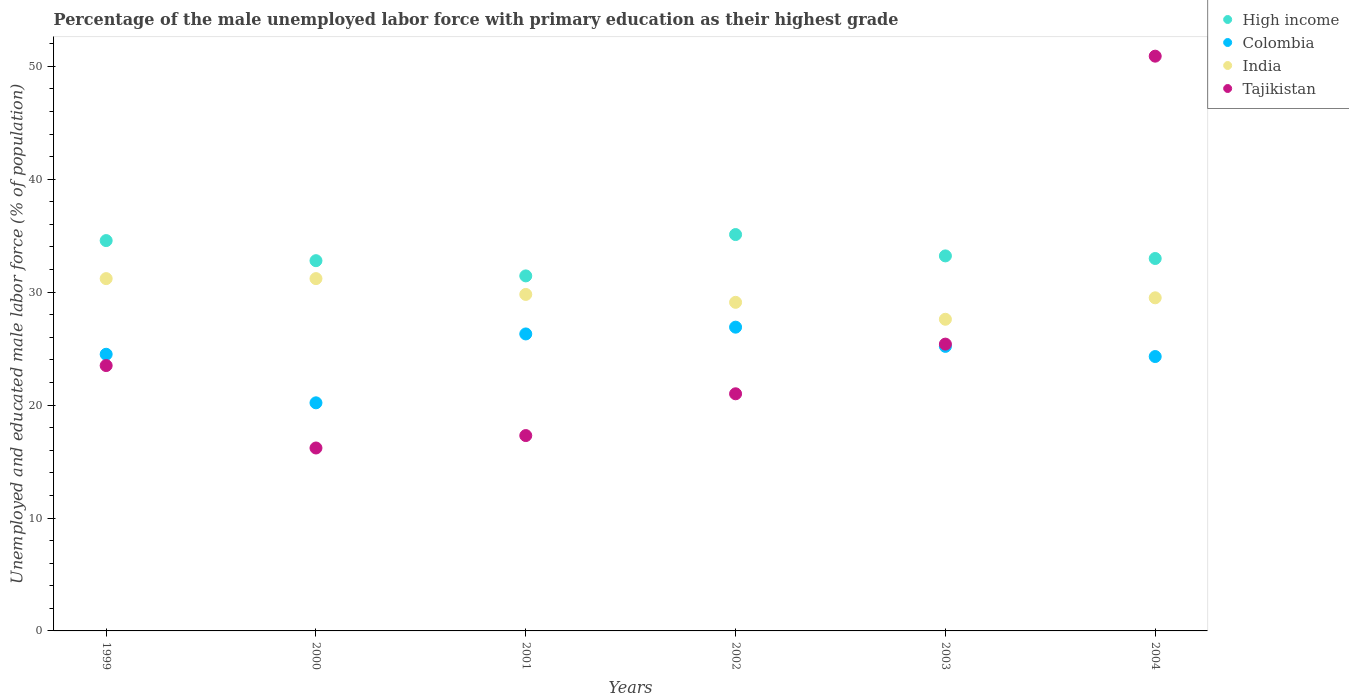How many different coloured dotlines are there?
Make the answer very short. 4. What is the percentage of the unemployed male labor force with primary education in Colombia in 1999?
Keep it short and to the point. 24.5. Across all years, what is the maximum percentage of the unemployed male labor force with primary education in India?
Provide a short and direct response. 31.2. Across all years, what is the minimum percentage of the unemployed male labor force with primary education in India?
Offer a terse response. 27.6. What is the total percentage of the unemployed male labor force with primary education in Colombia in the graph?
Provide a short and direct response. 147.4. What is the difference between the percentage of the unemployed male labor force with primary education in Tajikistan in 2001 and that in 2002?
Provide a short and direct response. -3.7. What is the difference between the percentage of the unemployed male labor force with primary education in Colombia in 1999 and the percentage of the unemployed male labor force with primary education in High income in 2001?
Offer a very short reply. -6.94. What is the average percentage of the unemployed male labor force with primary education in India per year?
Keep it short and to the point. 29.73. What is the ratio of the percentage of the unemployed male labor force with primary education in Tajikistan in 2000 to that in 2004?
Keep it short and to the point. 0.32. Is the percentage of the unemployed male labor force with primary education in India in 2002 less than that in 2004?
Ensure brevity in your answer.  Yes. Is the difference between the percentage of the unemployed male labor force with primary education in India in 2000 and 2003 greater than the difference between the percentage of the unemployed male labor force with primary education in Tajikistan in 2000 and 2003?
Your answer should be very brief. Yes. What is the difference between the highest and the second highest percentage of the unemployed male labor force with primary education in India?
Your response must be concise. 0. What is the difference between the highest and the lowest percentage of the unemployed male labor force with primary education in India?
Offer a very short reply. 3.6. Is the sum of the percentage of the unemployed male labor force with primary education in Colombia in 2000 and 2004 greater than the maximum percentage of the unemployed male labor force with primary education in India across all years?
Your answer should be compact. Yes. Is the percentage of the unemployed male labor force with primary education in High income strictly greater than the percentage of the unemployed male labor force with primary education in Colombia over the years?
Offer a terse response. Yes. Is the percentage of the unemployed male labor force with primary education in High income strictly less than the percentage of the unemployed male labor force with primary education in Tajikistan over the years?
Provide a short and direct response. No. How many years are there in the graph?
Provide a succinct answer. 6. How many legend labels are there?
Provide a succinct answer. 4. What is the title of the graph?
Give a very brief answer. Percentage of the male unemployed labor force with primary education as their highest grade. Does "Israel" appear as one of the legend labels in the graph?
Make the answer very short. No. What is the label or title of the Y-axis?
Give a very brief answer. Unemployed and educated male labor force (% of population). What is the Unemployed and educated male labor force (% of population) of High income in 1999?
Your response must be concise. 34.57. What is the Unemployed and educated male labor force (% of population) of Colombia in 1999?
Ensure brevity in your answer.  24.5. What is the Unemployed and educated male labor force (% of population) of India in 1999?
Keep it short and to the point. 31.2. What is the Unemployed and educated male labor force (% of population) of High income in 2000?
Offer a very short reply. 32.79. What is the Unemployed and educated male labor force (% of population) of Colombia in 2000?
Make the answer very short. 20.2. What is the Unemployed and educated male labor force (% of population) of India in 2000?
Keep it short and to the point. 31.2. What is the Unemployed and educated male labor force (% of population) in Tajikistan in 2000?
Offer a terse response. 16.2. What is the Unemployed and educated male labor force (% of population) in High income in 2001?
Your answer should be compact. 31.44. What is the Unemployed and educated male labor force (% of population) of Colombia in 2001?
Your response must be concise. 26.3. What is the Unemployed and educated male labor force (% of population) in India in 2001?
Keep it short and to the point. 29.8. What is the Unemployed and educated male labor force (% of population) of Tajikistan in 2001?
Ensure brevity in your answer.  17.3. What is the Unemployed and educated male labor force (% of population) of High income in 2002?
Your answer should be compact. 35.1. What is the Unemployed and educated male labor force (% of population) in Colombia in 2002?
Provide a short and direct response. 26.9. What is the Unemployed and educated male labor force (% of population) in India in 2002?
Your answer should be compact. 29.1. What is the Unemployed and educated male labor force (% of population) in Tajikistan in 2002?
Give a very brief answer. 21. What is the Unemployed and educated male labor force (% of population) in High income in 2003?
Provide a short and direct response. 33.21. What is the Unemployed and educated male labor force (% of population) in Colombia in 2003?
Keep it short and to the point. 25.2. What is the Unemployed and educated male labor force (% of population) of India in 2003?
Give a very brief answer. 27.6. What is the Unemployed and educated male labor force (% of population) of Tajikistan in 2003?
Give a very brief answer. 25.4. What is the Unemployed and educated male labor force (% of population) of High income in 2004?
Make the answer very short. 32.98. What is the Unemployed and educated male labor force (% of population) of Colombia in 2004?
Give a very brief answer. 24.3. What is the Unemployed and educated male labor force (% of population) of India in 2004?
Provide a short and direct response. 29.5. What is the Unemployed and educated male labor force (% of population) of Tajikistan in 2004?
Your answer should be very brief. 50.9. Across all years, what is the maximum Unemployed and educated male labor force (% of population) in High income?
Your answer should be compact. 35.1. Across all years, what is the maximum Unemployed and educated male labor force (% of population) of Colombia?
Keep it short and to the point. 26.9. Across all years, what is the maximum Unemployed and educated male labor force (% of population) in India?
Provide a short and direct response. 31.2. Across all years, what is the maximum Unemployed and educated male labor force (% of population) in Tajikistan?
Ensure brevity in your answer.  50.9. Across all years, what is the minimum Unemployed and educated male labor force (% of population) in High income?
Your answer should be very brief. 31.44. Across all years, what is the minimum Unemployed and educated male labor force (% of population) of Colombia?
Make the answer very short. 20.2. Across all years, what is the minimum Unemployed and educated male labor force (% of population) of India?
Your response must be concise. 27.6. Across all years, what is the minimum Unemployed and educated male labor force (% of population) of Tajikistan?
Provide a short and direct response. 16.2. What is the total Unemployed and educated male labor force (% of population) of High income in the graph?
Give a very brief answer. 200.09. What is the total Unemployed and educated male labor force (% of population) of Colombia in the graph?
Provide a succinct answer. 147.4. What is the total Unemployed and educated male labor force (% of population) in India in the graph?
Your answer should be very brief. 178.4. What is the total Unemployed and educated male labor force (% of population) of Tajikistan in the graph?
Keep it short and to the point. 154.3. What is the difference between the Unemployed and educated male labor force (% of population) of High income in 1999 and that in 2000?
Keep it short and to the point. 1.78. What is the difference between the Unemployed and educated male labor force (% of population) in Colombia in 1999 and that in 2000?
Give a very brief answer. 4.3. What is the difference between the Unemployed and educated male labor force (% of population) of India in 1999 and that in 2000?
Make the answer very short. 0. What is the difference between the Unemployed and educated male labor force (% of population) in Tajikistan in 1999 and that in 2000?
Provide a short and direct response. 7.3. What is the difference between the Unemployed and educated male labor force (% of population) of High income in 1999 and that in 2001?
Offer a terse response. 3.13. What is the difference between the Unemployed and educated male labor force (% of population) in High income in 1999 and that in 2002?
Offer a terse response. -0.53. What is the difference between the Unemployed and educated male labor force (% of population) in Tajikistan in 1999 and that in 2002?
Your answer should be compact. 2.5. What is the difference between the Unemployed and educated male labor force (% of population) in High income in 1999 and that in 2003?
Your answer should be compact. 1.36. What is the difference between the Unemployed and educated male labor force (% of population) of Colombia in 1999 and that in 2003?
Provide a short and direct response. -0.7. What is the difference between the Unemployed and educated male labor force (% of population) of India in 1999 and that in 2003?
Keep it short and to the point. 3.6. What is the difference between the Unemployed and educated male labor force (% of population) of High income in 1999 and that in 2004?
Your response must be concise. 1.59. What is the difference between the Unemployed and educated male labor force (% of population) in Colombia in 1999 and that in 2004?
Your answer should be compact. 0.2. What is the difference between the Unemployed and educated male labor force (% of population) in Tajikistan in 1999 and that in 2004?
Provide a short and direct response. -27.4. What is the difference between the Unemployed and educated male labor force (% of population) of High income in 2000 and that in 2001?
Offer a very short reply. 1.35. What is the difference between the Unemployed and educated male labor force (% of population) in Colombia in 2000 and that in 2001?
Your answer should be very brief. -6.1. What is the difference between the Unemployed and educated male labor force (% of population) of India in 2000 and that in 2001?
Ensure brevity in your answer.  1.4. What is the difference between the Unemployed and educated male labor force (% of population) of High income in 2000 and that in 2002?
Offer a terse response. -2.31. What is the difference between the Unemployed and educated male labor force (% of population) of India in 2000 and that in 2002?
Your response must be concise. 2.1. What is the difference between the Unemployed and educated male labor force (% of population) in Tajikistan in 2000 and that in 2002?
Offer a terse response. -4.8. What is the difference between the Unemployed and educated male labor force (% of population) of High income in 2000 and that in 2003?
Make the answer very short. -0.42. What is the difference between the Unemployed and educated male labor force (% of population) in India in 2000 and that in 2003?
Your response must be concise. 3.6. What is the difference between the Unemployed and educated male labor force (% of population) in Tajikistan in 2000 and that in 2003?
Provide a short and direct response. -9.2. What is the difference between the Unemployed and educated male labor force (% of population) of High income in 2000 and that in 2004?
Provide a short and direct response. -0.19. What is the difference between the Unemployed and educated male labor force (% of population) in Colombia in 2000 and that in 2004?
Offer a very short reply. -4.1. What is the difference between the Unemployed and educated male labor force (% of population) in Tajikistan in 2000 and that in 2004?
Make the answer very short. -34.7. What is the difference between the Unemployed and educated male labor force (% of population) of High income in 2001 and that in 2002?
Your response must be concise. -3.66. What is the difference between the Unemployed and educated male labor force (% of population) in Colombia in 2001 and that in 2002?
Provide a short and direct response. -0.6. What is the difference between the Unemployed and educated male labor force (% of population) in India in 2001 and that in 2002?
Provide a succinct answer. 0.7. What is the difference between the Unemployed and educated male labor force (% of population) in Tajikistan in 2001 and that in 2002?
Provide a succinct answer. -3.7. What is the difference between the Unemployed and educated male labor force (% of population) in High income in 2001 and that in 2003?
Your answer should be compact. -1.77. What is the difference between the Unemployed and educated male labor force (% of population) of India in 2001 and that in 2003?
Provide a short and direct response. 2.2. What is the difference between the Unemployed and educated male labor force (% of population) in High income in 2001 and that in 2004?
Provide a succinct answer. -1.54. What is the difference between the Unemployed and educated male labor force (% of population) in Colombia in 2001 and that in 2004?
Make the answer very short. 2. What is the difference between the Unemployed and educated male labor force (% of population) of Tajikistan in 2001 and that in 2004?
Your response must be concise. -33.6. What is the difference between the Unemployed and educated male labor force (% of population) of High income in 2002 and that in 2003?
Your answer should be compact. 1.89. What is the difference between the Unemployed and educated male labor force (% of population) of India in 2002 and that in 2003?
Provide a short and direct response. 1.5. What is the difference between the Unemployed and educated male labor force (% of population) of High income in 2002 and that in 2004?
Offer a terse response. 2.12. What is the difference between the Unemployed and educated male labor force (% of population) of India in 2002 and that in 2004?
Keep it short and to the point. -0.4. What is the difference between the Unemployed and educated male labor force (% of population) in Tajikistan in 2002 and that in 2004?
Provide a short and direct response. -29.9. What is the difference between the Unemployed and educated male labor force (% of population) in High income in 2003 and that in 2004?
Provide a succinct answer. 0.23. What is the difference between the Unemployed and educated male labor force (% of population) in Colombia in 2003 and that in 2004?
Provide a succinct answer. 0.9. What is the difference between the Unemployed and educated male labor force (% of population) of Tajikistan in 2003 and that in 2004?
Provide a succinct answer. -25.5. What is the difference between the Unemployed and educated male labor force (% of population) in High income in 1999 and the Unemployed and educated male labor force (% of population) in Colombia in 2000?
Offer a terse response. 14.37. What is the difference between the Unemployed and educated male labor force (% of population) of High income in 1999 and the Unemployed and educated male labor force (% of population) of India in 2000?
Your response must be concise. 3.37. What is the difference between the Unemployed and educated male labor force (% of population) in High income in 1999 and the Unemployed and educated male labor force (% of population) in Tajikistan in 2000?
Offer a terse response. 18.37. What is the difference between the Unemployed and educated male labor force (% of population) of India in 1999 and the Unemployed and educated male labor force (% of population) of Tajikistan in 2000?
Your response must be concise. 15. What is the difference between the Unemployed and educated male labor force (% of population) of High income in 1999 and the Unemployed and educated male labor force (% of population) of Colombia in 2001?
Make the answer very short. 8.27. What is the difference between the Unemployed and educated male labor force (% of population) of High income in 1999 and the Unemployed and educated male labor force (% of population) of India in 2001?
Your answer should be very brief. 4.77. What is the difference between the Unemployed and educated male labor force (% of population) of High income in 1999 and the Unemployed and educated male labor force (% of population) of Tajikistan in 2001?
Keep it short and to the point. 17.27. What is the difference between the Unemployed and educated male labor force (% of population) in Colombia in 1999 and the Unemployed and educated male labor force (% of population) in Tajikistan in 2001?
Provide a short and direct response. 7.2. What is the difference between the Unemployed and educated male labor force (% of population) of India in 1999 and the Unemployed and educated male labor force (% of population) of Tajikistan in 2001?
Offer a very short reply. 13.9. What is the difference between the Unemployed and educated male labor force (% of population) of High income in 1999 and the Unemployed and educated male labor force (% of population) of Colombia in 2002?
Keep it short and to the point. 7.67. What is the difference between the Unemployed and educated male labor force (% of population) of High income in 1999 and the Unemployed and educated male labor force (% of population) of India in 2002?
Your response must be concise. 5.47. What is the difference between the Unemployed and educated male labor force (% of population) in High income in 1999 and the Unemployed and educated male labor force (% of population) in Tajikistan in 2002?
Offer a terse response. 13.57. What is the difference between the Unemployed and educated male labor force (% of population) in High income in 1999 and the Unemployed and educated male labor force (% of population) in Colombia in 2003?
Provide a succinct answer. 9.37. What is the difference between the Unemployed and educated male labor force (% of population) in High income in 1999 and the Unemployed and educated male labor force (% of population) in India in 2003?
Offer a very short reply. 6.97. What is the difference between the Unemployed and educated male labor force (% of population) in High income in 1999 and the Unemployed and educated male labor force (% of population) in Tajikistan in 2003?
Ensure brevity in your answer.  9.17. What is the difference between the Unemployed and educated male labor force (% of population) in Colombia in 1999 and the Unemployed and educated male labor force (% of population) in India in 2003?
Offer a very short reply. -3.1. What is the difference between the Unemployed and educated male labor force (% of population) in India in 1999 and the Unemployed and educated male labor force (% of population) in Tajikistan in 2003?
Your response must be concise. 5.8. What is the difference between the Unemployed and educated male labor force (% of population) in High income in 1999 and the Unemployed and educated male labor force (% of population) in Colombia in 2004?
Your answer should be very brief. 10.27. What is the difference between the Unemployed and educated male labor force (% of population) of High income in 1999 and the Unemployed and educated male labor force (% of population) of India in 2004?
Give a very brief answer. 5.07. What is the difference between the Unemployed and educated male labor force (% of population) of High income in 1999 and the Unemployed and educated male labor force (% of population) of Tajikistan in 2004?
Your answer should be very brief. -16.33. What is the difference between the Unemployed and educated male labor force (% of population) in Colombia in 1999 and the Unemployed and educated male labor force (% of population) in Tajikistan in 2004?
Offer a terse response. -26.4. What is the difference between the Unemployed and educated male labor force (% of population) in India in 1999 and the Unemployed and educated male labor force (% of population) in Tajikistan in 2004?
Keep it short and to the point. -19.7. What is the difference between the Unemployed and educated male labor force (% of population) of High income in 2000 and the Unemployed and educated male labor force (% of population) of Colombia in 2001?
Your response must be concise. 6.49. What is the difference between the Unemployed and educated male labor force (% of population) in High income in 2000 and the Unemployed and educated male labor force (% of population) in India in 2001?
Your answer should be compact. 2.99. What is the difference between the Unemployed and educated male labor force (% of population) in High income in 2000 and the Unemployed and educated male labor force (% of population) in Tajikistan in 2001?
Keep it short and to the point. 15.49. What is the difference between the Unemployed and educated male labor force (% of population) of Colombia in 2000 and the Unemployed and educated male labor force (% of population) of India in 2001?
Give a very brief answer. -9.6. What is the difference between the Unemployed and educated male labor force (% of population) of India in 2000 and the Unemployed and educated male labor force (% of population) of Tajikistan in 2001?
Your answer should be very brief. 13.9. What is the difference between the Unemployed and educated male labor force (% of population) in High income in 2000 and the Unemployed and educated male labor force (% of population) in Colombia in 2002?
Provide a short and direct response. 5.89. What is the difference between the Unemployed and educated male labor force (% of population) in High income in 2000 and the Unemployed and educated male labor force (% of population) in India in 2002?
Make the answer very short. 3.69. What is the difference between the Unemployed and educated male labor force (% of population) in High income in 2000 and the Unemployed and educated male labor force (% of population) in Tajikistan in 2002?
Provide a short and direct response. 11.79. What is the difference between the Unemployed and educated male labor force (% of population) of Colombia in 2000 and the Unemployed and educated male labor force (% of population) of India in 2002?
Give a very brief answer. -8.9. What is the difference between the Unemployed and educated male labor force (% of population) in India in 2000 and the Unemployed and educated male labor force (% of population) in Tajikistan in 2002?
Provide a short and direct response. 10.2. What is the difference between the Unemployed and educated male labor force (% of population) of High income in 2000 and the Unemployed and educated male labor force (% of population) of Colombia in 2003?
Your response must be concise. 7.59. What is the difference between the Unemployed and educated male labor force (% of population) of High income in 2000 and the Unemployed and educated male labor force (% of population) of India in 2003?
Give a very brief answer. 5.19. What is the difference between the Unemployed and educated male labor force (% of population) in High income in 2000 and the Unemployed and educated male labor force (% of population) in Tajikistan in 2003?
Offer a very short reply. 7.39. What is the difference between the Unemployed and educated male labor force (% of population) of India in 2000 and the Unemployed and educated male labor force (% of population) of Tajikistan in 2003?
Offer a terse response. 5.8. What is the difference between the Unemployed and educated male labor force (% of population) of High income in 2000 and the Unemployed and educated male labor force (% of population) of Colombia in 2004?
Offer a terse response. 8.49. What is the difference between the Unemployed and educated male labor force (% of population) of High income in 2000 and the Unemployed and educated male labor force (% of population) of India in 2004?
Make the answer very short. 3.29. What is the difference between the Unemployed and educated male labor force (% of population) in High income in 2000 and the Unemployed and educated male labor force (% of population) in Tajikistan in 2004?
Your answer should be very brief. -18.11. What is the difference between the Unemployed and educated male labor force (% of population) in Colombia in 2000 and the Unemployed and educated male labor force (% of population) in Tajikistan in 2004?
Make the answer very short. -30.7. What is the difference between the Unemployed and educated male labor force (% of population) in India in 2000 and the Unemployed and educated male labor force (% of population) in Tajikistan in 2004?
Provide a succinct answer. -19.7. What is the difference between the Unemployed and educated male labor force (% of population) of High income in 2001 and the Unemployed and educated male labor force (% of population) of Colombia in 2002?
Your response must be concise. 4.54. What is the difference between the Unemployed and educated male labor force (% of population) of High income in 2001 and the Unemployed and educated male labor force (% of population) of India in 2002?
Your response must be concise. 2.34. What is the difference between the Unemployed and educated male labor force (% of population) of High income in 2001 and the Unemployed and educated male labor force (% of population) of Tajikistan in 2002?
Provide a short and direct response. 10.44. What is the difference between the Unemployed and educated male labor force (% of population) of High income in 2001 and the Unemployed and educated male labor force (% of population) of Colombia in 2003?
Make the answer very short. 6.24. What is the difference between the Unemployed and educated male labor force (% of population) in High income in 2001 and the Unemployed and educated male labor force (% of population) in India in 2003?
Your answer should be very brief. 3.84. What is the difference between the Unemployed and educated male labor force (% of population) of High income in 2001 and the Unemployed and educated male labor force (% of population) of Tajikistan in 2003?
Make the answer very short. 6.04. What is the difference between the Unemployed and educated male labor force (% of population) in Colombia in 2001 and the Unemployed and educated male labor force (% of population) in India in 2003?
Your answer should be compact. -1.3. What is the difference between the Unemployed and educated male labor force (% of population) of India in 2001 and the Unemployed and educated male labor force (% of population) of Tajikistan in 2003?
Provide a short and direct response. 4.4. What is the difference between the Unemployed and educated male labor force (% of population) of High income in 2001 and the Unemployed and educated male labor force (% of population) of Colombia in 2004?
Offer a terse response. 7.14. What is the difference between the Unemployed and educated male labor force (% of population) of High income in 2001 and the Unemployed and educated male labor force (% of population) of India in 2004?
Keep it short and to the point. 1.94. What is the difference between the Unemployed and educated male labor force (% of population) of High income in 2001 and the Unemployed and educated male labor force (% of population) of Tajikistan in 2004?
Your response must be concise. -19.46. What is the difference between the Unemployed and educated male labor force (% of population) of Colombia in 2001 and the Unemployed and educated male labor force (% of population) of India in 2004?
Offer a terse response. -3.2. What is the difference between the Unemployed and educated male labor force (% of population) in Colombia in 2001 and the Unemployed and educated male labor force (% of population) in Tajikistan in 2004?
Ensure brevity in your answer.  -24.6. What is the difference between the Unemployed and educated male labor force (% of population) of India in 2001 and the Unemployed and educated male labor force (% of population) of Tajikistan in 2004?
Offer a terse response. -21.1. What is the difference between the Unemployed and educated male labor force (% of population) in High income in 2002 and the Unemployed and educated male labor force (% of population) in Colombia in 2003?
Ensure brevity in your answer.  9.9. What is the difference between the Unemployed and educated male labor force (% of population) of High income in 2002 and the Unemployed and educated male labor force (% of population) of India in 2003?
Your answer should be compact. 7.5. What is the difference between the Unemployed and educated male labor force (% of population) of High income in 2002 and the Unemployed and educated male labor force (% of population) of Tajikistan in 2003?
Provide a succinct answer. 9.7. What is the difference between the Unemployed and educated male labor force (% of population) of Colombia in 2002 and the Unemployed and educated male labor force (% of population) of India in 2003?
Provide a short and direct response. -0.7. What is the difference between the Unemployed and educated male labor force (% of population) of High income in 2002 and the Unemployed and educated male labor force (% of population) of Colombia in 2004?
Your response must be concise. 10.8. What is the difference between the Unemployed and educated male labor force (% of population) in High income in 2002 and the Unemployed and educated male labor force (% of population) in India in 2004?
Offer a very short reply. 5.6. What is the difference between the Unemployed and educated male labor force (% of population) in High income in 2002 and the Unemployed and educated male labor force (% of population) in Tajikistan in 2004?
Give a very brief answer. -15.8. What is the difference between the Unemployed and educated male labor force (% of population) in Colombia in 2002 and the Unemployed and educated male labor force (% of population) in Tajikistan in 2004?
Offer a very short reply. -24. What is the difference between the Unemployed and educated male labor force (% of population) of India in 2002 and the Unemployed and educated male labor force (% of population) of Tajikistan in 2004?
Offer a very short reply. -21.8. What is the difference between the Unemployed and educated male labor force (% of population) of High income in 2003 and the Unemployed and educated male labor force (% of population) of Colombia in 2004?
Provide a succinct answer. 8.91. What is the difference between the Unemployed and educated male labor force (% of population) in High income in 2003 and the Unemployed and educated male labor force (% of population) in India in 2004?
Offer a very short reply. 3.71. What is the difference between the Unemployed and educated male labor force (% of population) of High income in 2003 and the Unemployed and educated male labor force (% of population) of Tajikistan in 2004?
Keep it short and to the point. -17.69. What is the difference between the Unemployed and educated male labor force (% of population) of Colombia in 2003 and the Unemployed and educated male labor force (% of population) of Tajikistan in 2004?
Your answer should be very brief. -25.7. What is the difference between the Unemployed and educated male labor force (% of population) in India in 2003 and the Unemployed and educated male labor force (% of population) in Tajikistan in 2004?
Keep it short and to the point. -23.3. What is the average Unemployed and educated male labor force (% of population) in High income per year?
Your answer should be very brief. 33.35. What is the average Unemployed and educated male labor force (% of population) in Colombia per year?
Keep it short and to the point. 24.57. What is the average Unemployed and educated male labor force (% of population) of India per year?
Your answer should be compact. 29.73. What is the average Unemployed and educated male labor force (% of population) in Tajikistan per year?
Give a very brief answer. 25.72. In the year 1999, what is the difference between the Unemployed and educated male labor force (% of population) of High income and Unemployed and educated male labor force (% of population) of Colombia?
Ensure brevity in your answer.  10.07. In the year 1999, what is the difference between the Unemployed and educated male labor force (% of population) in High income and Unemployed and educated male labor force (% of population) in India?
Give a very brief answer. 3.37. In the year 1999, what is the difference between the Unemployed and educated male labor force (% of population) in High income and Unemployed and educated male labor force (% of population) in Tajikistan?
Offer a very short reply. 11.07. In the year 1999, what is the difference between the Unemployed and educated male labor force (% of population) in Colombia and Unemployed and educated male labor force (% of population) in India?
Provide a succinct answer. -6.7. In the year 1999, what is the difference between the Unemployed and educated male labor force (% of population) in Colombia and Unemployed and educated male labor force (% of population) in Tajikistan?
Your answer should be very brief. 1. In the year 1999, what is the difference between the Unemployed and educated male labor force (% of population) of India and Unemployed and educated male labor force (% of population) of Tajikistan?
Your answer should be compact. 7.7. In the year 2000, what is the difference between the Unemployed and educated male labor force (% of population) in High income and Unemployed and educated male labor force (% of population) in Colombia?
Your answer should be compact. 12.59. In the year 2000, what is the difference between the Unemployed and educated male labor force (% of population) in High income and Unemployed and educated male labor force (% of population) in India?
Your answer should be compact. 1.59. In the year 2000, what is the difference between the Unemployed and educated male labor force (% of population) of High income and Unemployed and educated male labor force (% of population) of Tajikistan?
Give a very brief answer. 16.59. In the year 2000, what is the difference between the Unemployed and educated male labor force (% of population) of India and Unemployed and educated male labor force (% of population) of Tajikistan?
Make the answer very short. 15. In the year 2001, what is the difference between the Unemployed and educated male labor force (% of population) of High income and Unemployed and educated male labor force (% of population) of Colombia?
Keep it short and to the point. 5.14. In the year 2001, what is the difference between the Unemployed and educated male labor force (% of population) in High income and Unemployed and educated male labor force (% of population) in India?
Your answer should be very brief. 1.64. In the year 2001, what is the difference between the Unemployed and educated male labor force (% of population) of High income and Unemployed and educated male labor force (% of population) of Tajikistan?
Provide a short and direct response. 14.14. In the year 2001, what is the difference between the Unemployed and educated male labor force (% of population) of Colombia and Unemployed and educated male labor force (% of population) of Tajikistan?
Your answer should be very brief. 9. In the year 2001, what is the difference between the Unemployed and educated male labor force (% of population) of India and Unemployed and educated male labor force (% of population) of Tajikistan?
Give a very brief answer. 12.5. In the year 2002, what is the difference between the Unemployed and educated male labor force (% of population) in High income and Unemployed and educated male labor force (% of population) in Colombia?
Provide a succinct answer. 8.2. In the year 2002, what is the difference between the Unemployed and educated male labor force (% of population) in High income and Unemployed and educated male labor force (% of population) in India?
Provide a succinct answer. 6. In the year 2002, what is the difference between the Unemployed and educated male labor force (% of population) in High income and Unemployed and educated male labor force (% of population) in Tajikistan?
Offer a terse response. 14.1. In the year 2002, what is the difference between the Unemployed and educated male labor force (% of population) of Colombia and Unemployed and educated male labor force (% of population) of India?
Your answer should be compact. -2.2. In the year 2003, what is the difference between the Unemployed and educated male labor force (% of population) in High income and Unemployed and educated male labor force (% of population) in Colombia?
Ensure brevity in your answer.  8.01. In the year 2003, what is the difference between the Unemployed and educated male labor force (% of population) in High income and Unemployed and educated male labor force (% of population) in India?
Provide a succinct answer. 5.61. In the year 2003, what is the difference between the Unemployed and educated male labor force (% of population) in High income and Unemployed and educated male labor force (% of population) in Tajikistan?
Your answer should be very brief. 7.81. In the year 2004, what is the difference between the Unemployed and educated male labor force (% of population) of High income and Unemployed and educated male labor force (% of population) of Colombia?
Provide a succinct answer. 8.68. In the year 2004, what is the difference between the Unemployed and educated male labor force (% of population) of High income and Unemployed and educated male labor force (% of population) of India?
Provide a short and direct response. 3.48. In the year 2004, what is the difference between the Unemployed and educated male labor force (% of population) of High income and Unemployed and educated male labor force (% of population) of Tajikistan?
Your answer should be compact. -17.92. In the year 2004, what is the difference between the Unemployed and educated male labor force (% of population) of Colombia and Unemployed and educated male labor force (% of population) of Tajikistan?
Your response must be concise. -26.6. In the year 2004, what is the difference between the Unemployed and educated male labor force (% of population) of India and Unemployed and educated male labor force (% of population) of Tajikistan?
Provide a succinct answer. -21.4. What is the ratio of the Unemployed and educated male labor force (% of population) in High income in 1999 to that in 2000?
Give a very brief answer. 1.05. What is the ratio of the Unemployed and educated male labor force (% of population) in Colombia in 1999 to that in 2000?
Your response must be concise. 1.21. What is the ratio of the Unemployed and educated male labor force (% of population) of Tajikistan in 1999 to that in 2000?
Offer a very short reply. 1.45. What is the ratio of the Unemployed and educated male labor force (% of population) in High income in 1999 to that in 2001?
Ensure brevity in your answer.  1.1. What is the ratio of the Unemployed and educated male labor force (% of population) in Colombia in 1999 to that in 2001?
Offer a terse response. 0.93. What is the ratio of the Unemployed and educated male labor force (% of population) in India in 1999 to that in 2001?
Offer a very short reply. 1.05. What is the ratio of the Unemployed and educated male labor force (% of population) of Tajikistan in 1999 to that in 2001?
Give a very brief answer. 1.36. What is the ratio of the Unemployed and educated male labor force (% of population) of High income in 1999 to that in 2002?
Ensure brevity in your answer.  0.98. What is the ratio of the Unemployed and educated male labor force (% of population) in Colombia in 1999 to that in 2002?
Provide a short and direct response. 0.91. What is the ratio of the Unemployed and educated male labor force (% of population) of India in 1999 to that in 2002?
Provide a short and direct response. 1.07. What is the ratio of the Unemployed and educated male labor force (% of population) in Tajikistan in 1999 to that in 2002?
Provide a succinct answer. 1.12. What is the ratio of the Unemployed and educated male labor force (% of population) of High income in 1999 to that in 2003?
Provide a short and direct response. 1.04. What is the ratio of the Unemployed and educated male labor force (% of population) of Colombia in 1999 to that in 2003?
Your answer should be compact. 0.97. What is the ratio of the Unemployed and educated male labor force (% of population) in India in 1999 to that in 2003?
Ensure brevity in your answer.  1.13. What is the ratio of the Unemployed and educated male labor force (% of population) of Tajikistan in 1999 to that in 2003?
Provide a short and direct response. 0.93. What is the ratio of the Unemployed and educated male labor force (% of population) of High income in 1999 to that in 2004?
Keep it short and to the point. 1.05. What is the ratio of the Unemployed and educated male labor force (% of population) of Colombia in 1999 to that in 2004?
Your answer should be compact. 1.01. What is the ratio of the Unemployed and educated male labor force (% of population) in India in 1999 to that in 2004?
Your answer should be compact. 1.06. What is the ratio of the Unemployed and educated male labor force (% of population) in Tajikistan in 1999 to that in 2004?
Give a very brief answer. 0.46. What is the ratio of the Unemployed and educated male labor force (% of population) of High income in 2000 to that in 2001?
Offer a terse response. 1.04. What is the ratio of the Unemployed and educated male labor force (% of population) of Colombia in 2000 to that in 2001?
Your response must be concise. 0.77. What is the ratio of the Unemployed and educated male labor force (% of population) of India in 2000 to that in 2001?
Your answer should be compact. 1.05. What is the ratio of the Unemployed and educated male labor force (% of population) in Tajikistan in 2000 to that in 2001?
Your response must be concise. 0.94. What is the ratio of the Unemployed and educated male labor force (% of population) in High income in 2000 to that in 2002?
Make the answer very short. 0.93. What is the ratio of the Unemployed and educated male labor force (% of population) of Colombia in 2000 to that in 2002?
Provide a succinct answer. 0.75. What is the ratio of the Unemployed and educated male labor force (% of population) in India in 2000 to that in 2002?
Ensure brevity in your answer.  1.07. What is the ratio of the Unemployed and educated male labor force (% of population) of Tajikistan in 2000 to that in 2002?
Offer a terse response. 0.77. What is the ratio of the Unemployed and educated male labor force (% of population) in High income in 2000 to that in 2003?
Offer a very short reply. 0.99. What is the ratio of the Unemployed and educated male labor force (% of population) of Colombia in 2000 to that in 2003?
Ensure brevity in your answer.  0.8. What is the ratio of the Unemployed and educated male labor force (% of population) of India in 2000 to that in 2003?
Keep it short and to the point. 1.13. What is the ratio of the Unemployed and educated male labor force (% of population) of Tajikistan in 2000 to that in 2003?
Provide a succinct answer. 0.64. What is the ratio of the Unemployed and educated male labor force (% of population) in Colombia in 2000 to that in 2004?
Your answer should be very brief. 0.83. What is the ratio of the Unemployed and educated male labor force (% of population) in India in 2000 to that in 2004?
Provide a succinct answer. 1.06. What is the ratio of the Unemployed and educated male labor force (% of population) of Tajikistan in 2000 to that in 2004?
Offer a very short reply. 0.32. What is the ratio of the Unemployed and educated male labor force (% of population) of High income in 2001 to that in 2002?
Ensure brevity in your answer.  0.9. What is the ratio of the Unemployed and educated male labor force (% of population) of Colombia in 2001 to that in 2002?
Keep it short and to the point. 0.98. What is the ratio of the Unemployed and educated male labor force (% of population) in India in 2001 to that in 2002?
Offer a terse response. 1.02. What is the ratio of the Unemployed and educated male labor force (% of population) in Tajikistan in 2001 to that in 2002?
Keep it short and to the point. 0.82. What is the ratio of the Unemployed and educated male labor force (% of population) of High income in 2001 to that in 2003?
Give a very brief answer. 0.95. What is the ratio of the Unemployed and educated male labor force (% of population) in Colombia in 2001 to that in 2003?
Ensure brevity in your answer.  1.04. What is the ratio of the Unemployed and educated male labor force (% of population) of India in 2001 to that in 2003?
Offer a very short reply. 1.08. What is the ratio of the Unemployed and educated male labor force (% of population) in Tajikistan in 2001 to that in 2003?
Provide a short and direct response. 0.68. What is the ratio of the Unemployed and educated male labor force (% of population) in High income in 2001 to that in 2004?
Ensure brevity in your answer.  0.95. What is the ratio of the Unemployed and educated male labor force (% of population) of Colombia in 2001 to that in 2004?
Provide a short and direct response. 1.08. What is the ratio of the Unemployed and educated male labor force (% of population) in India in 2001 to that in 2004?
Ensure brevity in your answer.  1.01. What is the ratio of the Unemployed and educated male labor force (% of population) of Tajikistan in 2001 to that in 2004?
Offer a terse response. 0.34. What is the ratio of the Unemployed and educated male labor force (% of population) in High income in 2002 to that in 2003?
Provide a short and direct response. 1.06. What is the ratio of the Unemployed and educated male labor force (% of population) in Colombia in 2002 to that in 2003?
Provide a short and direct response. 1.07. What is the ratio of the Unemployed and educated male labor force (% of population) in India in 2002 to that in 2003?
Provide a succinct answer. 1.05. What is the ratio of the Unemployed and educated male labor force (% of population) in Tajikistan in 2002 to that in 2003?
Offer a terse response. 0.83. What is the ratio of the Unemployed and educated male labor force (% of population) in High income in 2002 to that in 2004?
Offer a very short reply. 1.06. What is the ratio of the Unemployed and educated male labor force (% of population) of Colombia in 2002 to that in 2004?
Your response must be concise. 1.11. What is the ratio of the Unemployed and educated male labor force (% of population) of India in 2002 to that in 2004?
Keep it short and to the point. 0.99. What is the ratio of the Unemployed and educated male labor force (% of population) of Tajikistan in 2002 to that in 2004?
Your answer should be very brief. 0.41. What is the ratio of the Unemployed and educated male labor force (% of population) in India in 2003 to that in 2004?
Your response must be concise. 0.94. What is the ratio of the Unemployed and educated male labor force (% of population) of Tajikistan in 2003 to that in 2004?
Offer a very short reply. 0.5. What is the difference between the highest and the second highest Unemployed and educated male labor force (% of population) in High income?
Provide a succinct answer. 0.53. What is the difference between the highest and the second highest Unemployed and educated male labor force (% of population) of Colombia?
Offer a terse response. 0.6. What is the difference between the highest and the second highest Unemployed and educated male labor force (% of population) in India?
Your response must be concise. 0. What is the difference between the highest and the second highest Unemployed and educated male labor force (% of population) in Tajikistan?
Keep it short and to the point. 25.5. What is the difference between the highest and the lowest Unemployed and educated male labor force (% of population) in High income?
Provide a succinct answer. 3.66. What is the difference between the highest and the lowest Unemployed and educated male labor force (% of population) in Tajikistan?
Give a very brief answer. 34.7. 